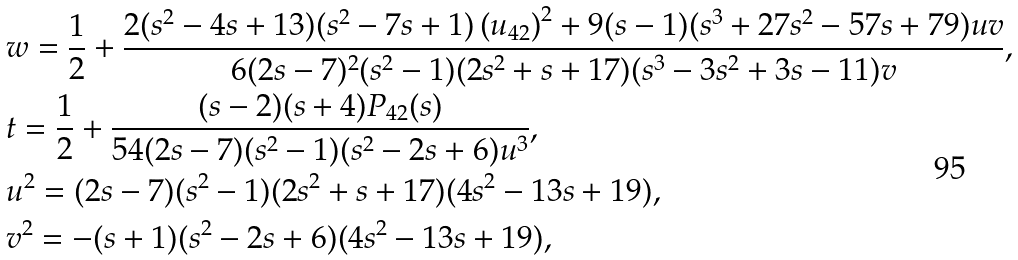Convert formula to latex. <formula><loc_0><loc_0><loc_500><loc_500>& w = \frac { 1 } { 2 } + \frac { 2 ( s ^ { 2 } - 4 s + 1 3 ) ( s ^ { 2 } - 7 s + 1 ) \left ( u _ { 4 2 } \right ) ^ { 2 } + 9 ( s - 1 ) ( s ^ { 3 } + 2 7 s ^ { 2 } - 5 7 s + 7 9 ) u v } { 6 ( 2 s - 7 ) ^ { 2 } ( s ^ { 2 } - 1 ) ( 2 s ^ { 2 } + s + 1 7 ) ( s ^ { 3 } - 3 s ^ { 2 } + 3 s - 1 1 ) v } , \\ & t = \frac { 1 } { 2 } + \frac { ( s - 2 ) ( s + 4 ) P _ { 4 2 } ( s ) } { 5 4 ( 2 s - 7 ) ( s ^ { 2 } - 1 ) ( s ^ { 2 } - 2 s + 6 ) u ^ { 3 } } , \\ & u ^ { 2 } = ( 2 s - 7 ) ( s ^ { 2 } - 1 ) ( 2 s ^ { 2 } + s + 1 7 ) ( 4 s ^ { 2 } - 1 3 s + 1 9 ) , \\ & v ^ { 2 } = - ( s + 1 ) ( s ^ { 2 } - 2 s + 6 ) ( 4 s ^ { 2 } - 1 3 s + 1 9 ) ,</formula> 